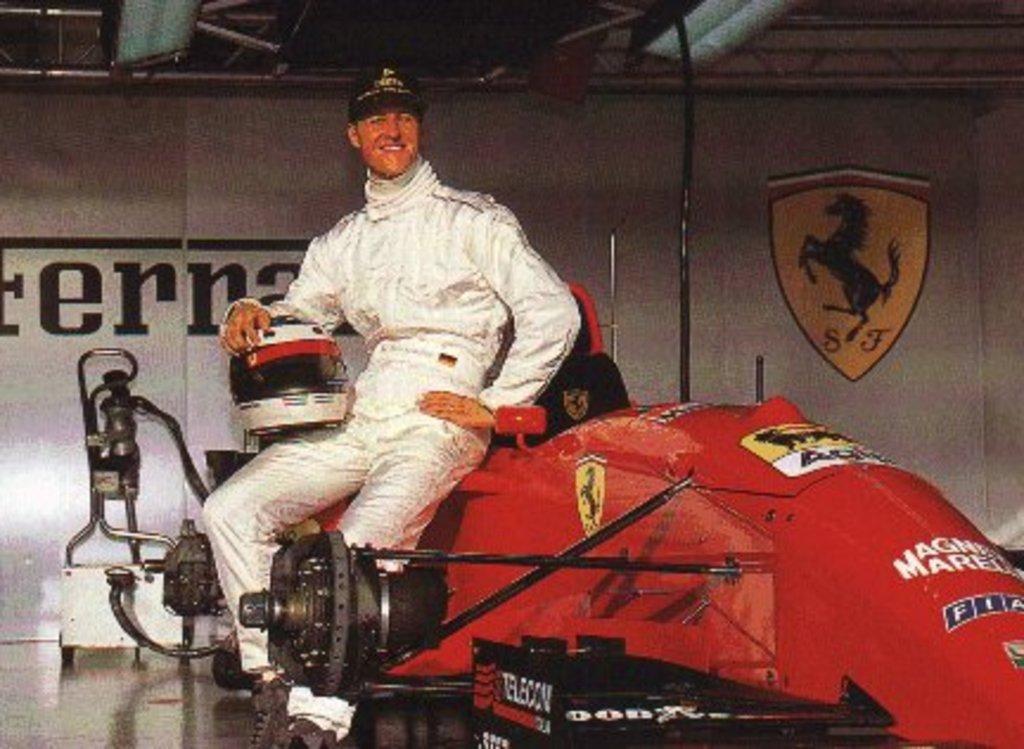Could you give a brief overview of what you see in this image? In this image we can see a man holding a helmet sitting on a vehicle which is placed on the surface. On the backside we can see a pipe and a wall with some text and a picture on it. 